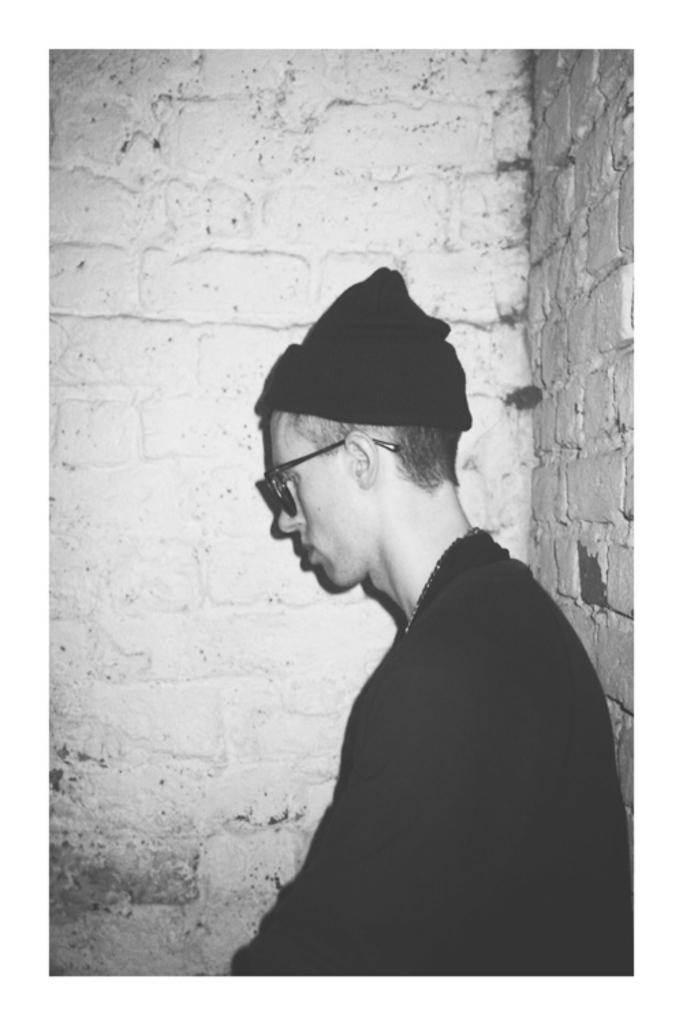What can be seen in the image related to a person? There is a person in the image. What is the person wearing on their upper body? The person is wearing a black T-shirt. What accessory is the person wearing on their face? The person has spectacles on their eyes. What type of headwear is the person wearing? The person is wearing a hat. What type of background can be seen in the image? There is a brick wall beside the person and a brick wall behind the person. Is the person's sister visible in the image? There is no mention of a sister in the image, so it cannot be determined if the person's sister is present. 